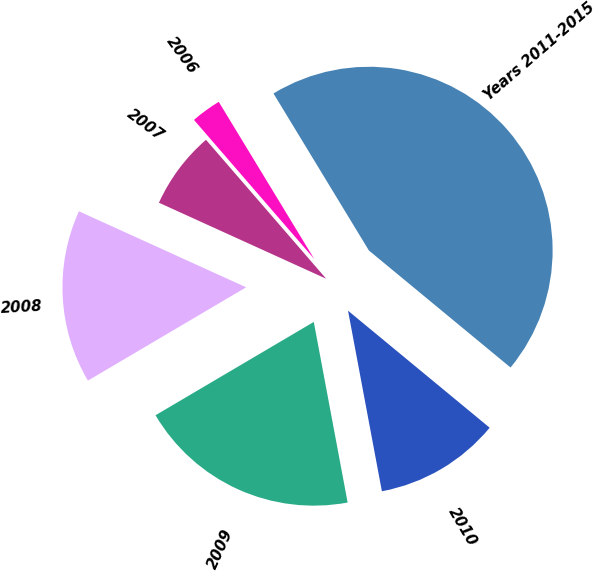<chart> <loc_0><loc_0><loc_500><loc_500><pie_chart><fcel>2006<fcel>2007<fcel>2008<fcel>2009<fcel>2010<fcel>Years 2011-2015<nl><fcel>2.66%<fcel>6.86%<fcel>15.27%<fcel>19.47%<fcel>11.06%<fcel>44.68%<nl></chart> 